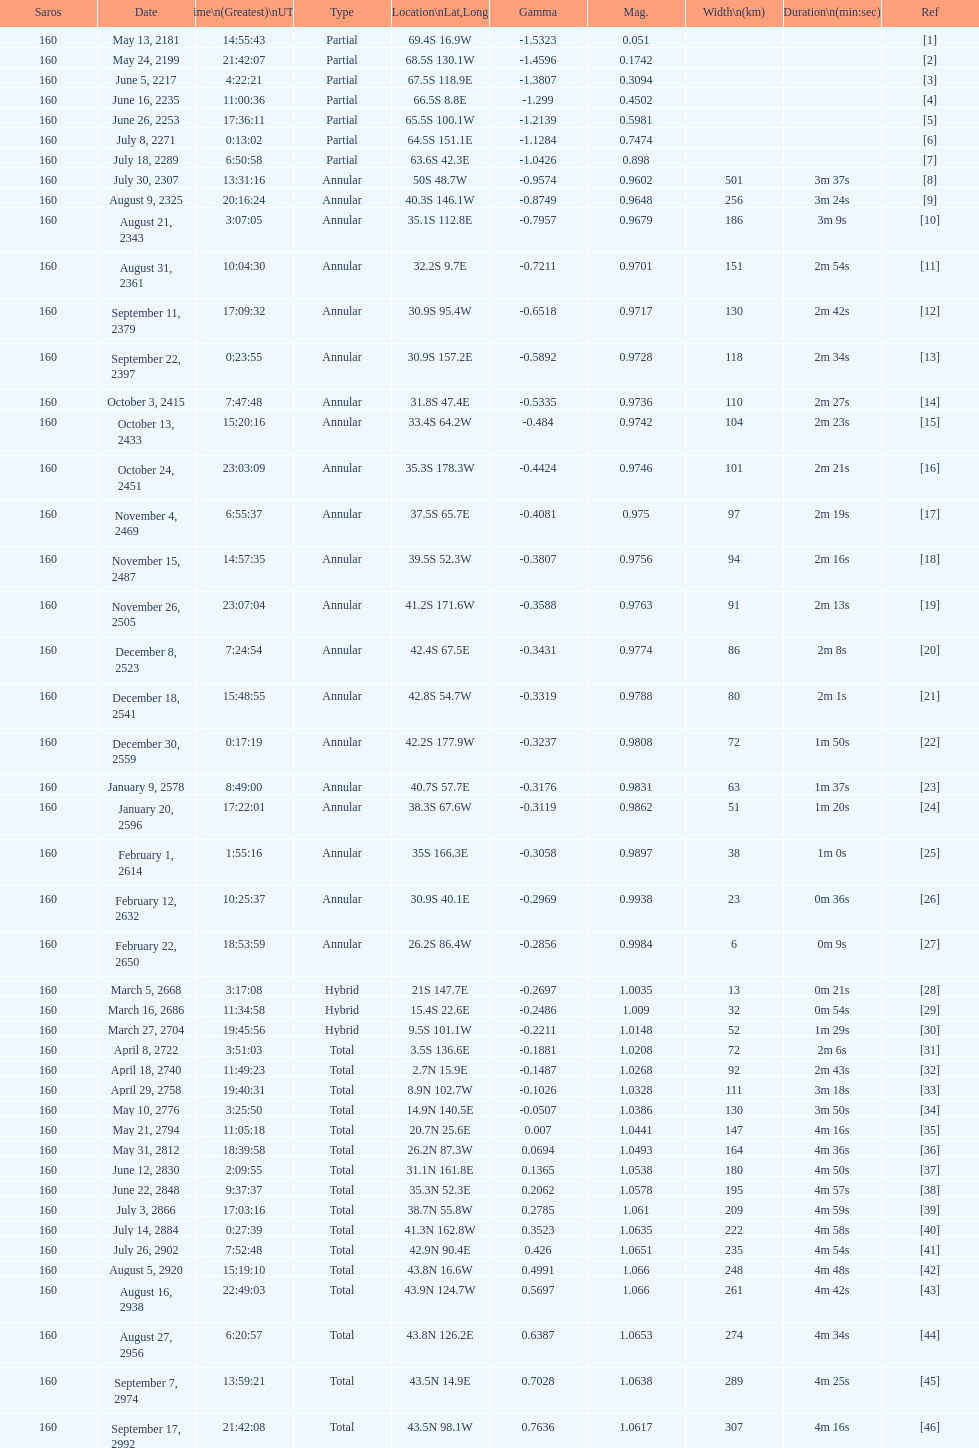How many partial members will occur before the first annular? 7. 